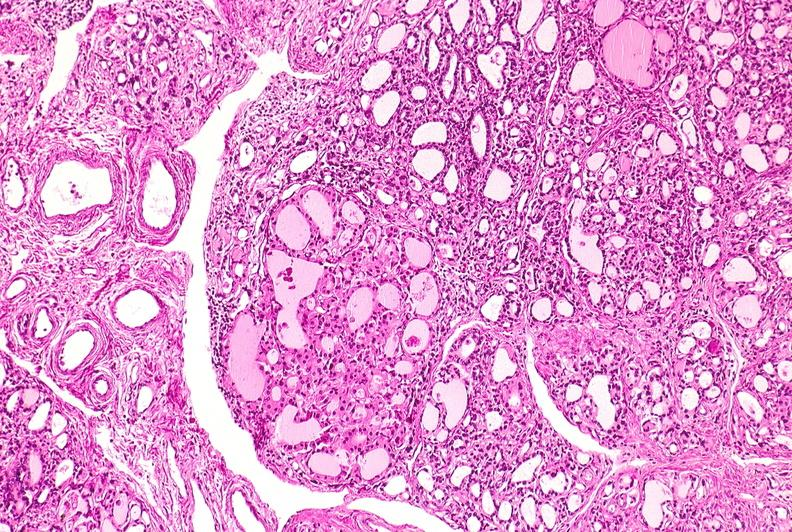s endocrine present?
Answer the question using a single word or phrase. Yes 